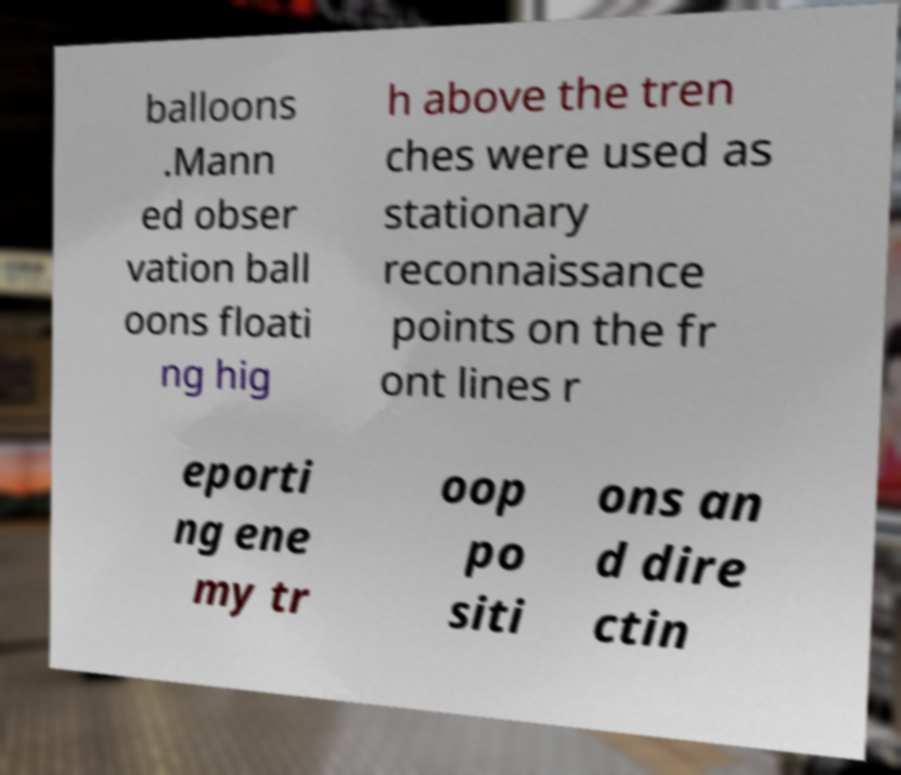For documentation purposes, I need the text within this image transcribed. Could you provide that? balloons .Mann ed obser vation ball oons floati ng hig h above the tren ches were used as stationary reconnaissance points on the fr ont lines r eporti ng ene my tr oop po siti ons an d dire ctin 